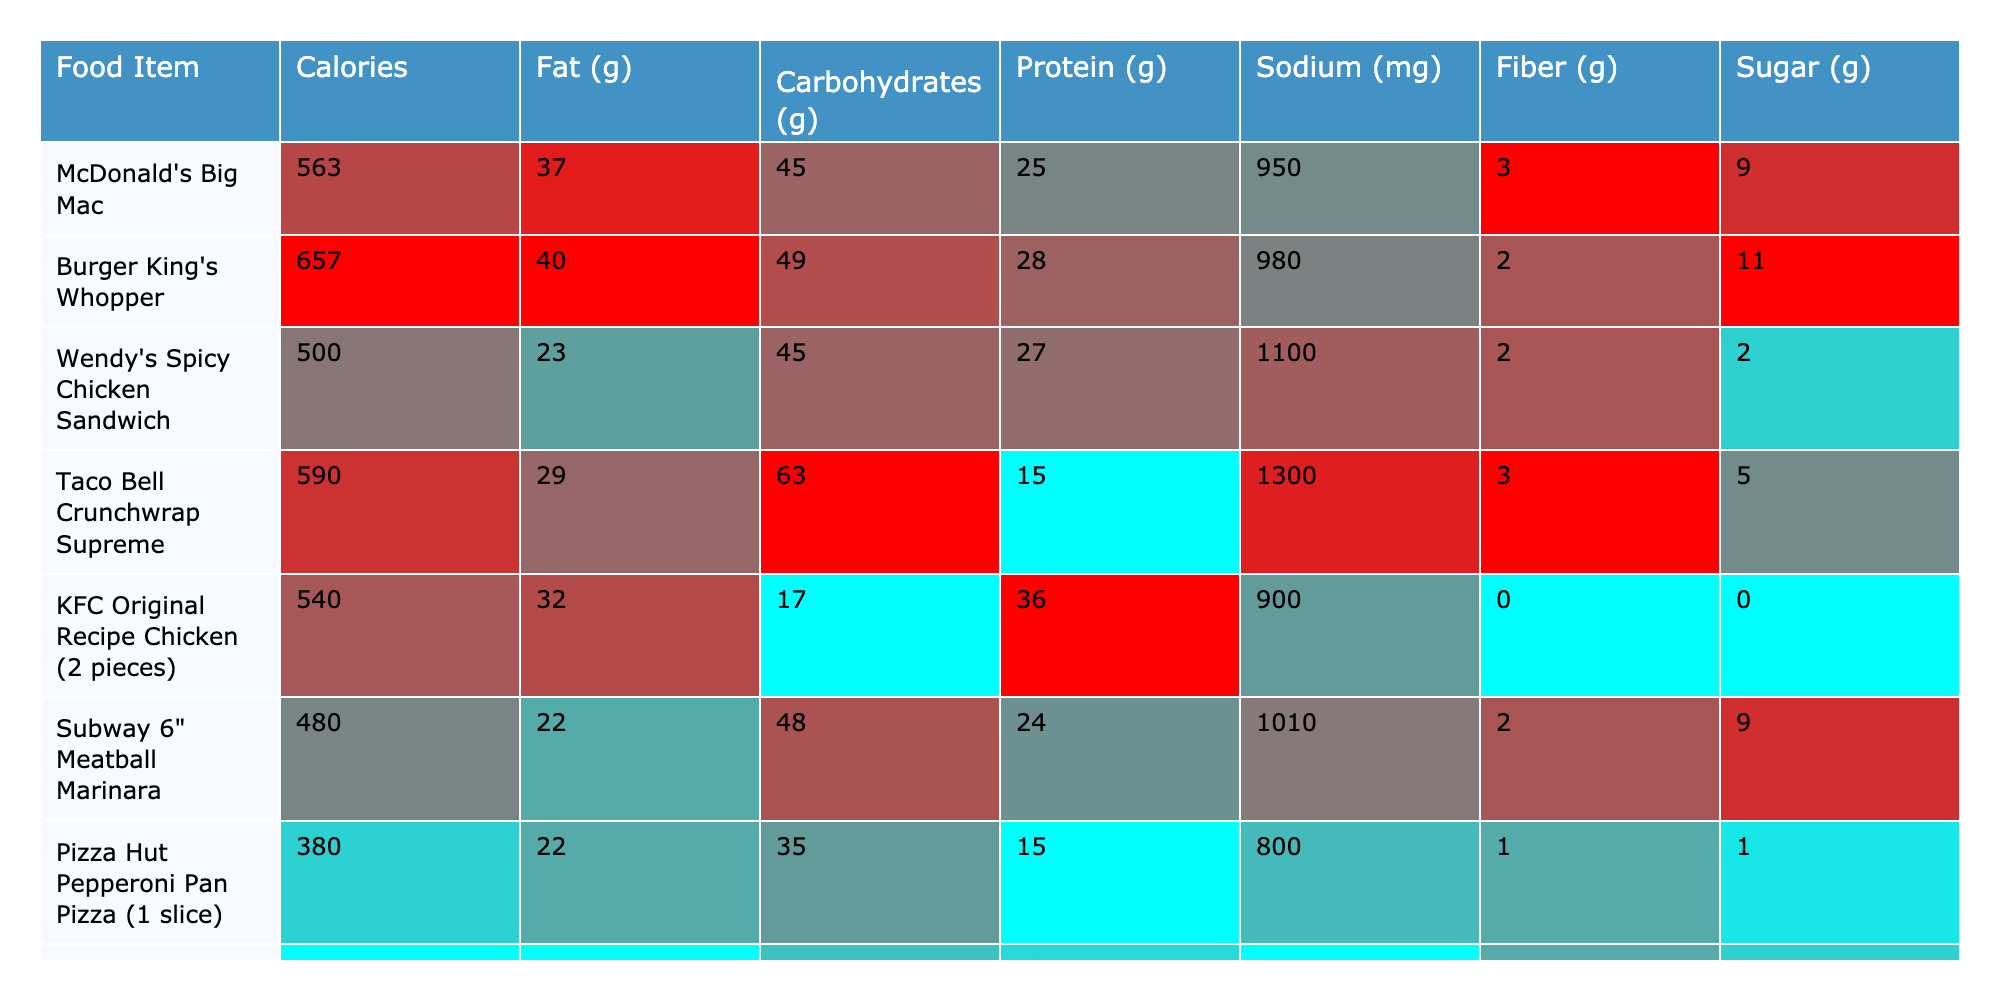What is the calorie content of Burger King's Whopper? The table lists Burger King's Whopper with a calorie content of 657.
Answer: 657 Which fast food item has the highest fat content? By examining the Fat (g) column, Burger King's Whopper has the highest fat content at 40 grams.
Answer: 40 grams What is the protein content of the Subway 6" Meatball Marinara? The protein content for Subway 6" Meatball Marinara is found in the Protein (g) column, which is 24 grams.
Answer: 24 grams How many total grams of carbohydrates do McDonald's Big Mac and Wendy's Spicy Chicken Sandwich have together? McDonald's Big Mac has 45 grams of carbohydrates, and Wendy's Spicy Chicken Sandwich has 45 grams as well. Adding these gives: 45 + 45 = 90 grams of carbohydrates.
Answer: 90 grams Is the sodium content of KFC Original Recipe Chicken higher than that of the Chick-fil-A Chicken Sandwich? KFC has a sodium content of 900 mg, while Chick-fil-A has a sodium content of 1400 mg. Since 1400 mg is greater than 900 mg, the statement is true.
Answer: Yes How much more sugar does the Burger King's Whopper have compared to Pizza Hut's Pepperoni Pan Pizza? The Whopper contains 11 grams of sugar, and Pizza Hut's Pepperoni Pan Pizza has 1 gram. The difference is 11 - 1 = 10 grams.
Answer: 10 grams What is the average calorie content of all the fast food items listed? The total calories of all items are (563 + 657 + 500 + 590 + 540 + 480 + 380 + 320 + 440) = 4160. There are 9 items, so the average is 4160 / 9 = 462.22, approximately 462.
Answer: 462 Which food item has the least amount of fiber? Looking at the Fiber (g) column, KFC Original Recipe Chicken has 0 grams of fiber, which is the least among all items.
Answer: 0 grams How many grams of fat does the Taco Bell Crunchwrap Supreme have compared to the Wendy's Spicy Chicken Sandwich? Taco Bell Crunchwrap Supreme has 29 grams of fat, while Wendy's Spicy Chicken Sandwich has 23 grams. The difference is 29 - 23 = 6 grams.
Answer: 6 grams Is the sodium content of the Starbucks Bacon & Gouda Breakfast Sandwich lower than that of the Subway 6" Meatball Marinara? The sodium content for Starbucks is 580 mg and for Subway is 1010 mg. Since 580 mg is lower than 1010 mg, the statement is true.
Answer: Yes 